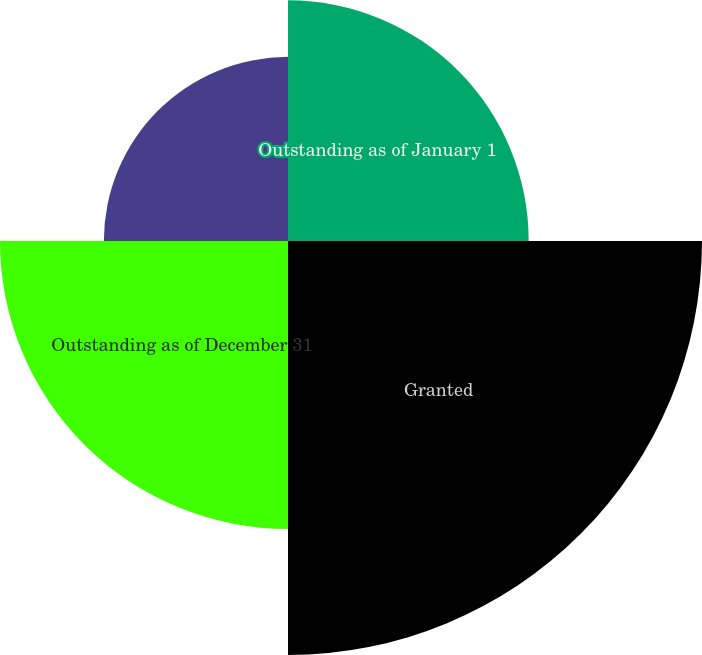<chart> <loc_0><loc_0><loc_500><loc_500><pie_chart><fcel>Outstanding as of January 1<fcel>Granted<fcel>Outstanding as of December 31<fcel>Exercisable as of December 31<nl><fcel>21.36%<fcel>36.74%<fcel>25.56%<fcel>16.34%<nl></chart> 